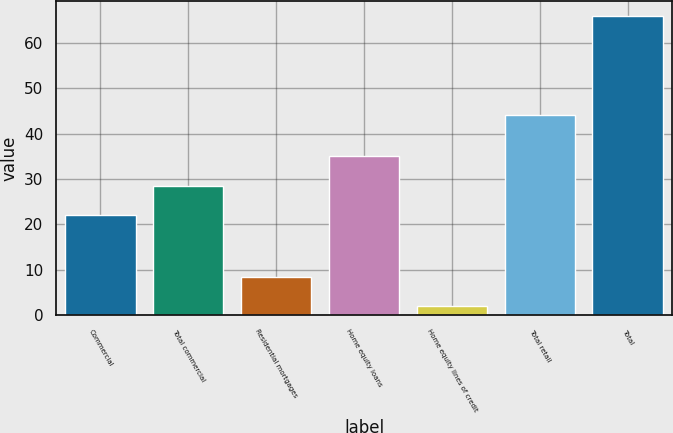<chart> <loc_0><loc_0><loc_500><loc_500><bar_chart><fcel>Commercial<fcel>Total commercial<fcel>Residential mortgages<fcel>Home equity loans<fcel>Home equity lines of credit<fcel>Total retail<fcel>Total<nl><fcel>22<fcel>28.4<fcel>8.4<fcel>35<fcel>2<fcel>44<fcel>66<nl></chart> 